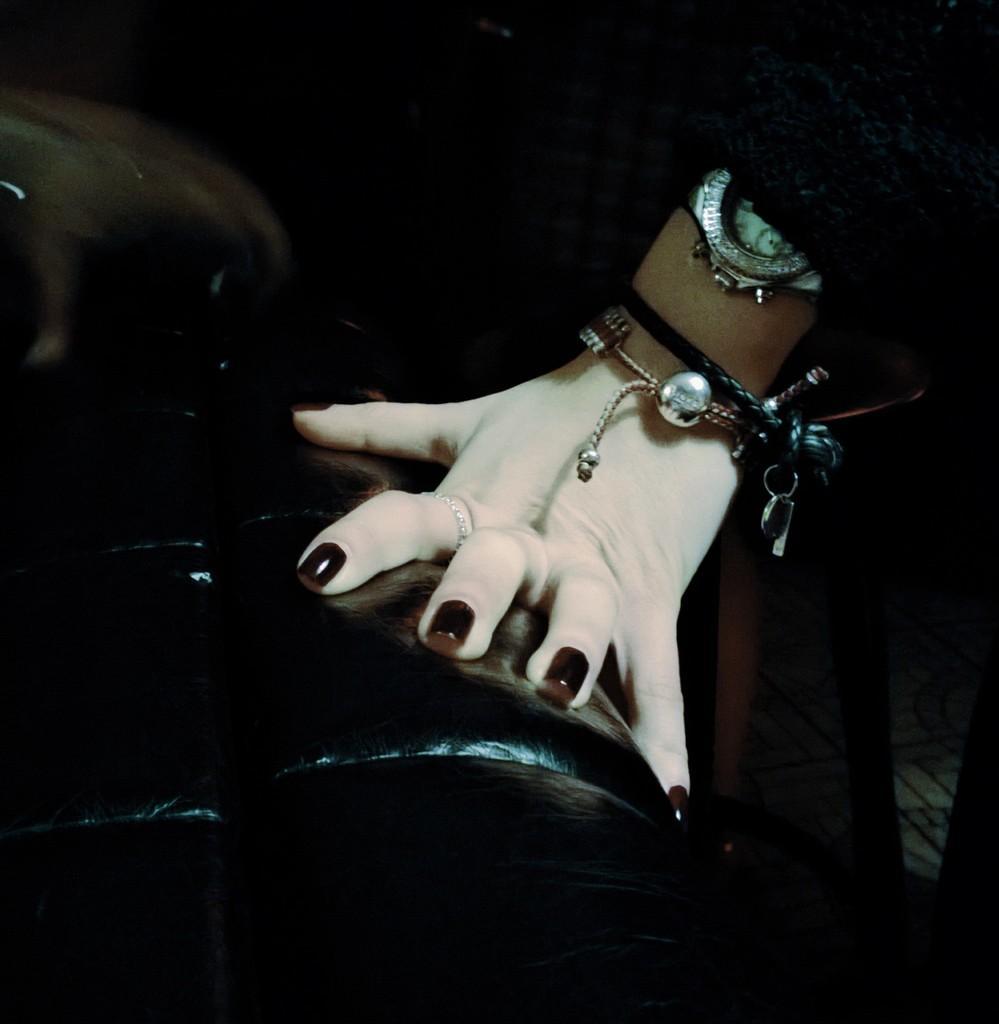Could you give a brief overview of what you see in this image? In this image I can see a person's hand on the black colored object. I can see the person is wearing black colored dress and a watch. 